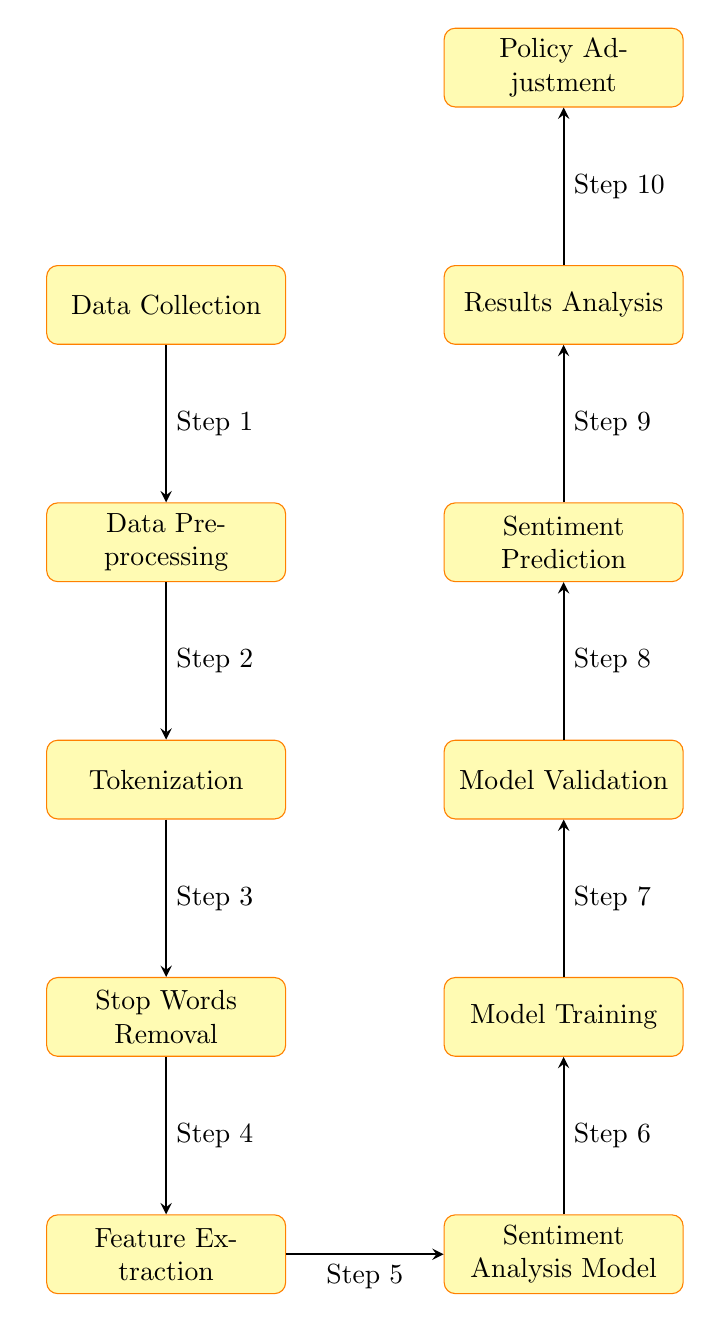What is the first step in the diagram? The first step is labeled as "Step 1," which is data collection. This is the initial node in the process flowchart.
Answer: Data Collection How many steps are in the process? By counting each arrow labeled as "Step" from the data collection to policy adjustment, there are a total of ten distinct steps outlined in the diagram.
Answer: Ten Which step immediately follows model training? After model training, the next step in the sequence is model validation. This is evident by following the arrow that points from model training upward to the next node.
Answer: Model Validation What is the purpose of the step titled "Feature Extraction"? The purpose of feature extraction is to transform the text data into meaningful numerical representations that can be used for analysis, indicated by its position in the flow before the model is used.
Answer: Transform data Which node represents the final outcome of this process? The final outcome is represented by the node titled "Policy Adjustment," which is the last process in the flow leading from results analysis.
Answer: Policy Adjustment What is the relationship between tokenization and stop words removal? Tokenization is the step that precedes stop words removal; hence, it serves as the input for the stop words removal process, indicating a direct sequential relation.
Answer: Sequential List the steps in the order of processing from data collection to sentiment prediction. The order of processing based on the diagram starts with data collection, followed by data preprocessing, tokenization, stop words removal, feature extraction, and then leads to sentiment prediction.
Answer: Data Collection, Data Preprocessing, Tokenization, Stop Words Removal, Feature Extraction, Sentiment Prediction Which two steps are positioned directly above sentiment prediction in the diagram? The two steps positioned directly above sentiment prediction are model validation and model training, showing they precede the prediction phase in the workflow.
Answer: Model Validation, Model Training What kind of data is primarily collected in the initial step? The data collected in the initial step is primarily social media data, which is implied as this analysis focuses on public opinion regarding economic policies.
Answer: Social Media Data What follows results analysis in the diagram? The step that follows results analysis, as indicated by the flow of the diagram, is policy adjustment. This shows the purpose of analyzing results is to inform adjustments in policies.
Answer: Policy Adjustment 